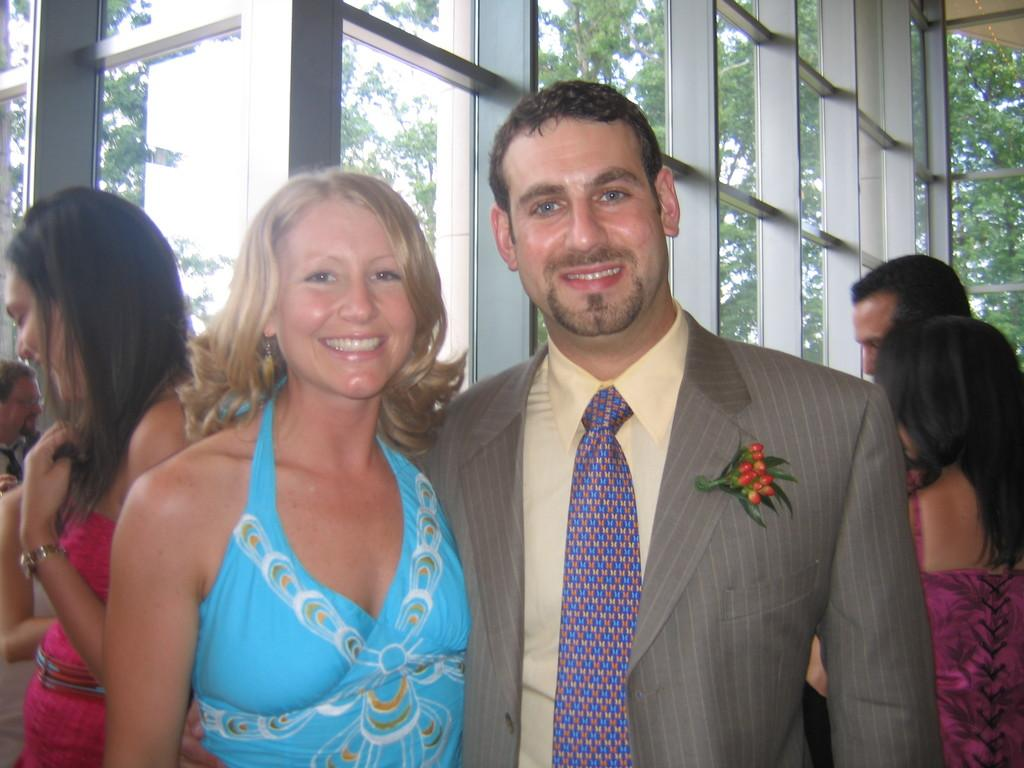What type of building is shown in the image? The image shows an inner view of a building made of glass. How many people are present in the image? There are seven people in the image. Can you describe the gender distribution of the people in the image? Three of the people are men, and four of the people are women. What can be seen outside the building? There are many trees outside the building. How does the mom in the image compare to the other people in terms of height? There is no mention of a mom in the image, so it is not possible to make a comparison based on that information. 